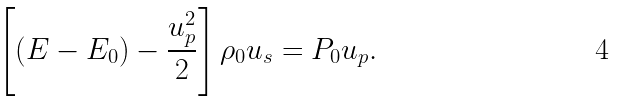Convert formula to latex. <formula><loc_0><loc_0><loc_500><loc_500>\left [ \left ( E - E _ { 0 } \right ) - \frac { u _ { p } ^ { 2 } } 2 \right ] \rho _ { 0 } u _ { s } = P _ { 0 } u _ { p } .</formula> 